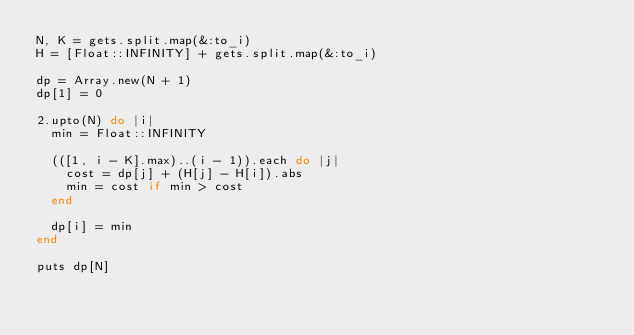<code> <loc_0><loc_0><loc_500><loc_500><_Ruby_>N, K = gets.split.map(&:to_i)
H = [Float::INFINITY] + gets.split.map(&:to_i)

dp = Array.new(N + 1)
dp[1] = 0

2.upto(N) do |i|
  min = Float::INFINITY

  (([1, i - K].max)..(i - 1)).each do |j|
    cost = dp[j] + (H[j] - H[i]).abs
    min = cost if min > cost
  end

  dp[i] = min
end

puts dp[N]
</code> 